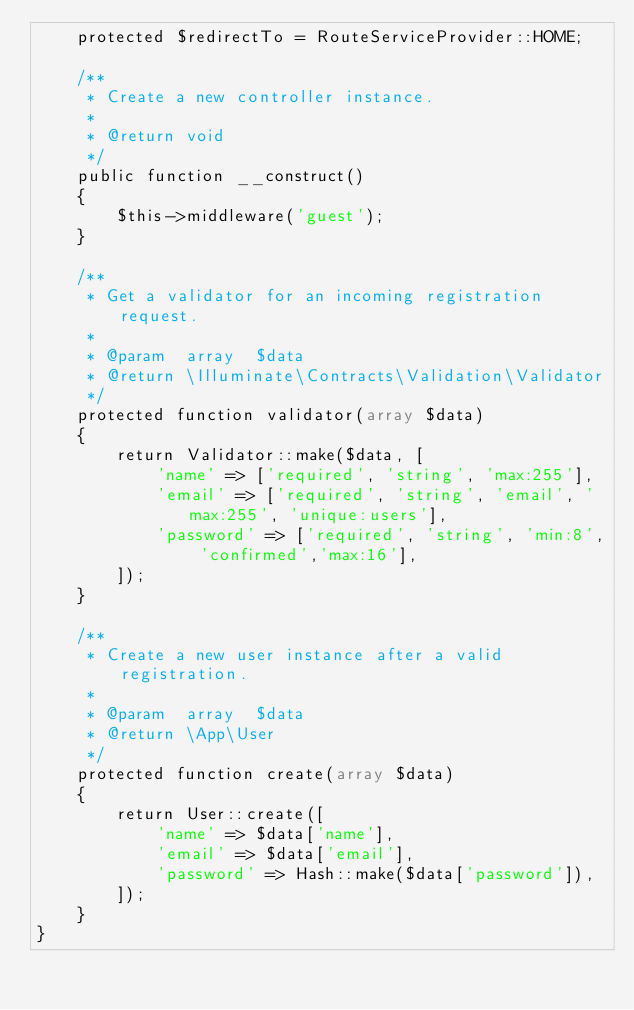<code> <loc_0><loc_0><loc_500><loc_500><_PHP_>    protected $redirectTo = RouteServiceProvider::HOME;

    /**
     * Create a new controller instance.
     *
     * @return void
     */
    public function __construct()
    {
        $this->middleware('guest');
    }

    /**
     * Get a validator for an incoming registration request.
     *
     * @param  array  $data
     * @return \Illuminate\Contracts\Validation\Validator
     */
    protected function validator(array $data)
    {
        return Validator::make($data, [
            'name' => ['required', 'string', 'max:255'],
            'email' => ['required', 'string', 'email', 'max:255', 'unique:users'],
            'password' => ['required', 'string', 'min:8', 'confirmed','max:16'],
        ]);
    }

    /**
     * Create a new user instance after a valid registration.
     *
     * @param  array  $data
     * @return \App\User
     */
    protected function create(array $data)
    {
        return User::create([
            'name' => $data['name'],
            'email' => $data['email'],
            'password' => Hash::make($data['password']),
        ]);
    }
}
</code> 